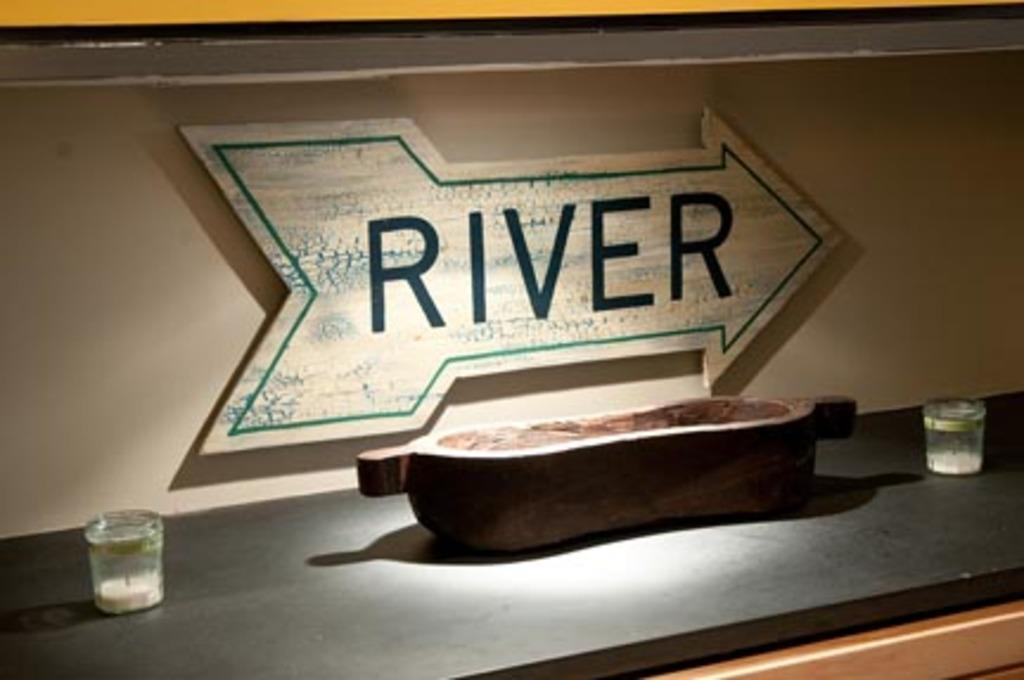<image>
Write a terse but informative summary of the picture. A sign in the shape of an arrow points to the right, the sign reads river. 